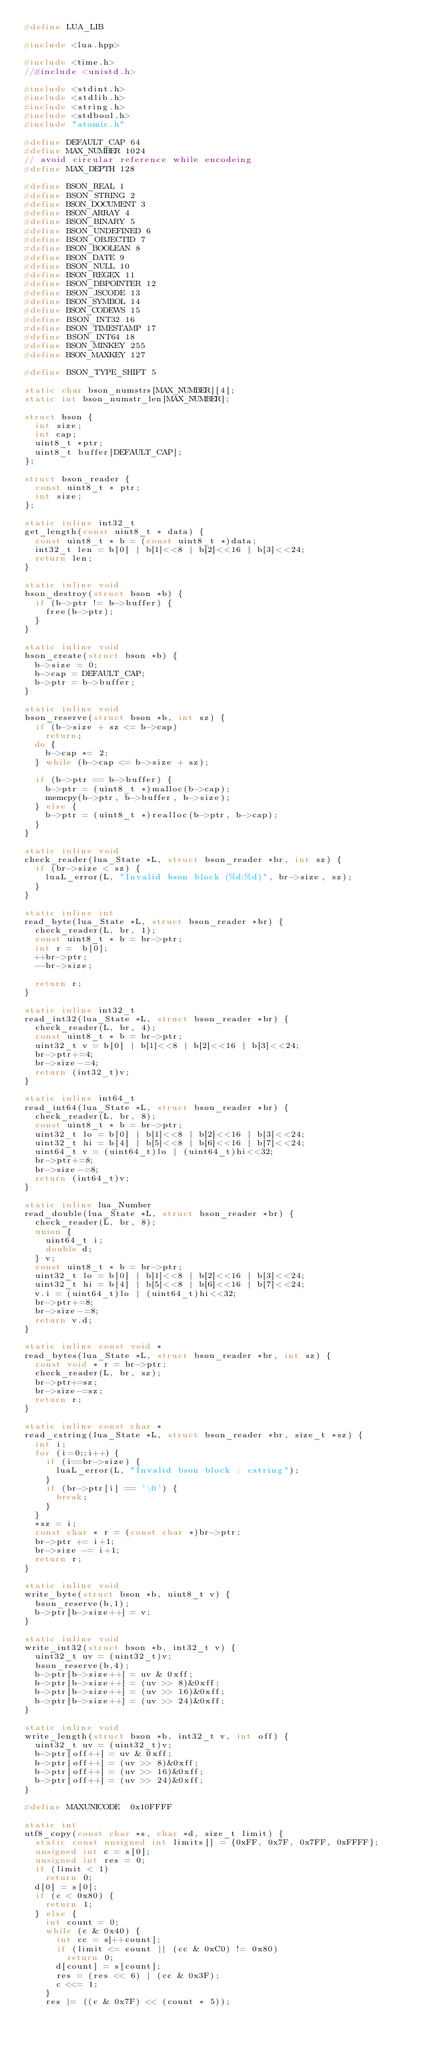<code> <loc_0><loc_0><loc_500><loc_500><_C++_>#define LUA_LIB

#include <lua.hpp>

#include <time.h>
//#include <unistd.h>

#include <stdint.h>
#include <stdlib.h>
#include <string.h>
#include <stdbool.h>
#include "atomic.h"

#define DEFAULT_CAP 64
#define MAX_NUMBER 1024
// avoid circular reference while encodeing
#define MAX_DEPTH 128

#define BSON_REAL 1
#define BSON_STRING 2
#define BSON_DOCUMENT 3
#define BSON_ARRAY 4
#define BSON_BINARY 5
#define BSON_UNDEFINED 6
#define BSON_OBJECTID 7
#define BSON_BOOLEAN 8
#define BSON_DATE 9
#define BSON_NULL 10
#define BSON_REGEX 11
#define BSON_DBPOINTER 12
#define BSON_JSCODE 13
#define BSON_SYMBOL 14
#define BSON_CODEWS 15
#define BSON_INT32 16
#define BSON_TIMESTAMP 17
#define BSON_INT64 18
#define BSON_MINKEY 255
#define BSON_MAXKEY 127

#define BSON_TYPE_SHIFT 5

static char bson_numstrs[MAX_NUMBER][4];
static int bson_numstr_len[MAX_NUMBER];

struct bson {
	int size;
	int cap;
	uint8_t *ptr;
	uint8_t buffer[DEFAULT_CAP];
};

struct bson_reader {
	const uint8_t * ptr;
	int size;
};

static inline int32_t
get_length(const uint8_t * data) {
	const uint8_t * b = (const uint8_t *)data;
	int32_t len = b[0] | b[1]<<8 | b[2]<<16 | b[3]<<24;
	return len;
}

static inline void
bson_destroy(struct bson *b) {
	if (b->ptr != b->buffer) {
		free(b->ptr);
	}
}

static inline void
bson_create(struct bson *b) {
	b->size = 0;
	b->cap = DEFAULT_CAP;
	b->ptr = b->buffer;
}

static inline void
bson_reserve(struct bson *b, int sz) {
	if (b->size + sz <= b->cap)
		return;
	do {
		b->cap *= 2;
	} while (b->cap <= b->size + sz);

	if (b->ptr == b->buffer) {
		b->ptr = (uint8_t *)malloc(b->cap);
		memcpy(b->ptr, b->buffer, b->size);
	} else {
		b->ptr = (uint8_t *)realloc(b->ptr, b->cap);
	}
}

static inline void
check_reader(lua_State *L, struct bson_reader *br, int sz) {
	if (br->size < sz) {
		luaL_error(L, "Invalid bson block (%d:%d)", br->size, sz);
	}
}

static inline int
read_byte(lua_State *L, struct bson_reader *br) {
	check_reader(L, br, 1);
	const uint8_t * b = br->ptr;
	int r =  b[0];
	++br->ptr;
	--br->size;

	return r;
}

static inline int32_t
read_int32(lua_State *L, struct bson_reader *br) {
	check_reader(L, br, 4);
	const uint8_t * b = br->ptr;
	uint32_t v = b[0] | b[1]<<8 | b[2]<<16 | b[3]<<24;
	br->ptr+=4;
	br->size-=4;
	return (int32_t)v;
}

static inline int64_t
read_int64(lua_State *L, struct bson_reader *br) {
	check_reader(L, br, 8);
	const uint8_t * b = br->ptr;
	uint32_t lo = b[0] | b[1]<<8 | b[2]<<16 | b[3]<<24;
	uint32_t hi = b[4] | b[5]<<8 | b[6]<<16 | b[7]<<24;
	uint64_t v = (uint64_t)lo | (uint64_t)hi<<32;
	br->ptr+=8;
	br->size-=8;
	return (int64_t)v;
}

static inline lua_Number
read_double(lua_State *L, struct bson_reader *br) {
	check_reader(L, br, 8);
	union {
		uint64_t i;
		double d;
	} v;
	const uint8_t * b = br->ptr;
	uint32_t lo = b[0] | b[1]<<8 | b[2]<<16 | b[3]<<24;
	uint32_t hi = b[4] | b[5]<<8 | b[6]<<16 | b[7]<<24;
	v.i = (uint64_t)lo | (uint64_t)hi<<32;
	br->ptr+=8;
	br->size-=8;
	return v.d;
}

static inline const void *
read_bytes(lua_State *L, struct bson_reader *br, int sz) {
	const void * r = br->ptr;
	check_reader(L, br, sz);
	br->ptr+=sz;
	br->size-=sz;
	return r;
}

static inline const char *
read_cstring(lua_State *L, struct bson_reader *br, size_t *sz) {
	int i;
	for (i=0;;i++) {
		if (i==br->size) {
			luaL_error(L, "Invalid bson block : cstring");
		}
		if (br->ptr[i] == '\0') {
			break;
		}
	}
	*sz = i;
	const char * r = (const char *)br->ptr;
	br->ptr += i+1;
	br->size -= i+1;
	return r;
}

static inline void
write_byte(struct bson *b, uint8_t v) {
	bson_reserve(b,1);
	b->ptr[b->size++] = v;
}

static inline void
write_int32(struct bson *b, int32_t v) {
	uint32_t uv = (uint32_t)v;
	bson_reserve(b,4);
	b->ptr[b->size++] = uv & 0xff;
	b->ptr[b->size++] = (uv >> 8)&0xff;
	b->ptr[b->size++] = (uv >> 16)&0xff;
	b->ptr[b->size++] = (uv >> 24)&0xff;
}

static inline void
write_length(struct bson *b, int32_t v, int off) {
	uint32_t uv = (uint32_t)v;
	b->ptr[off++] = uv & 0xff;
	b->ptr[off++] = (uv >> 8)&0xff;
	b->ptr[off++] = (uv >> 16)&0xff;
	b->ptr[off++] = (uv >> 24)&0xff;
}

#define MAXUNICODE	0x10FFFF

static int
utf8_copy(const char *s, char *d, size_t limit) {
	static const unsigned int limits[] = {0xFF, 0x7F, 0x7FF, 0xFFFF};
	unsigned int c = s[0];
	unsigned int res = 0;
	if (limit < 1)
		return 0;
	d[0] = s[0];
	if (c < 0x80) {
		return 1;
	} else {
		int count = 0;
		while (c & 0x40) {
			int cc = s[++count];
			if (limit <= count || (cc & 0xC0) != 0x80)
				return 0;
			d[count] = s[count];
			res = (res << 6) | (cc & 0x3F);
			c <<= 1;
		}
		res |= ((c & 0x7F) << (count * 5));</code> 